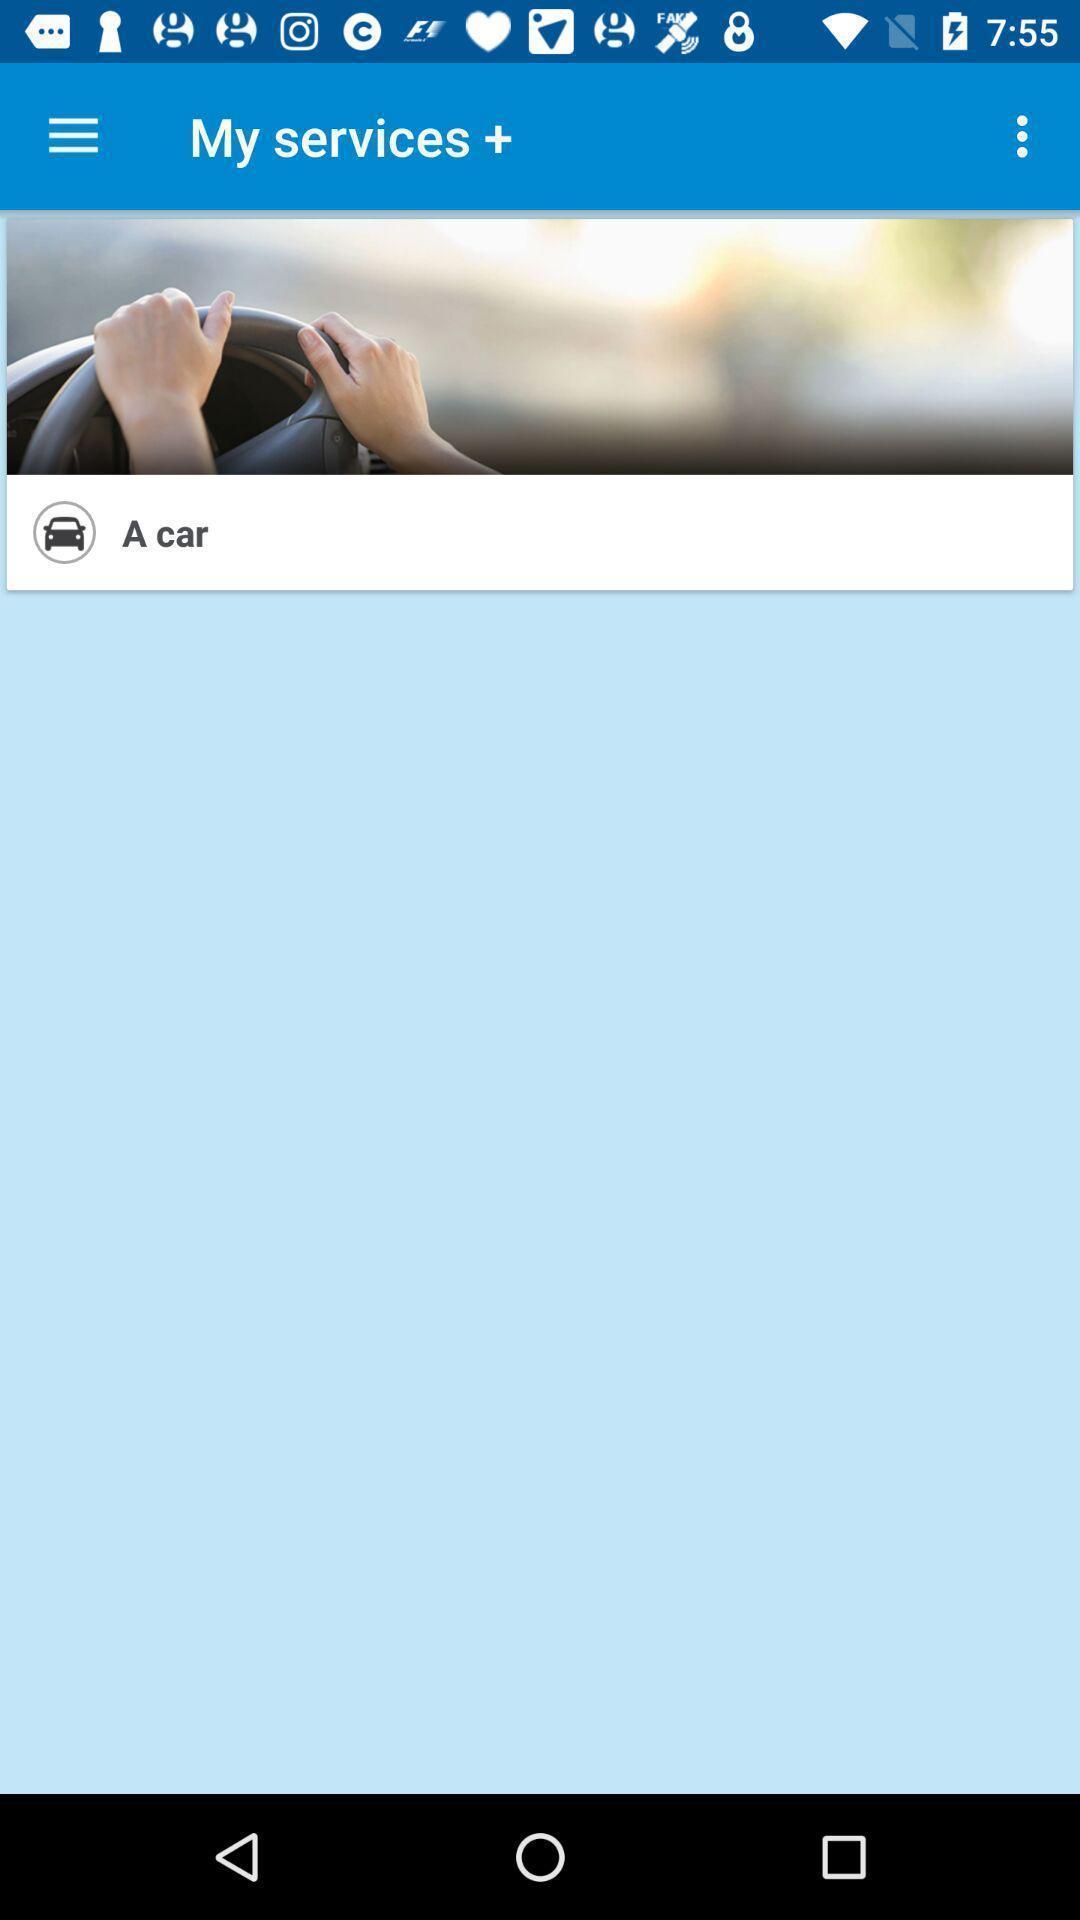Provide a description of this screenshot. Page displaying services of app. 